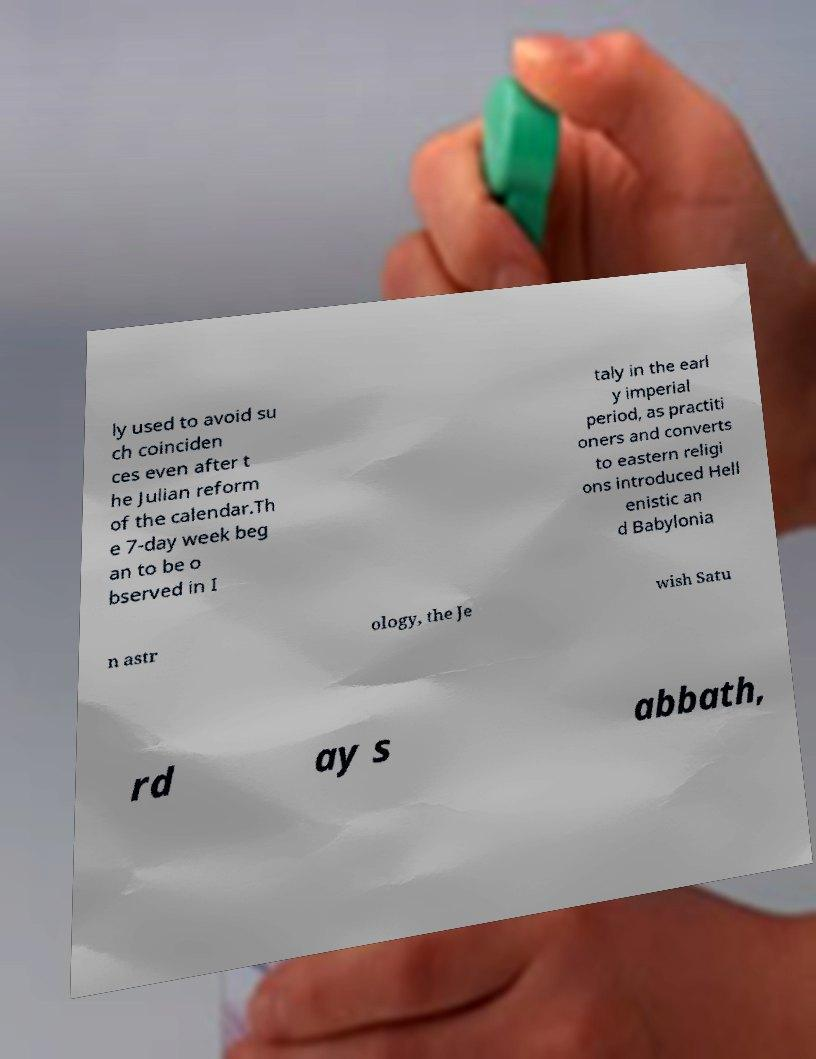Can you accurately transcribe the text from the provided image for me? ly used to avoid su ch coinciden ces even after t he Julian reform of the calendar.Th e 7-day week beg an to be o bserved in I taly in the earl y imperial period, as practiti oners and converts to eastern religi ons introduced Hell enistic an d Babylonia n astr ology, the Je wish Satu rd ay s abbath, 